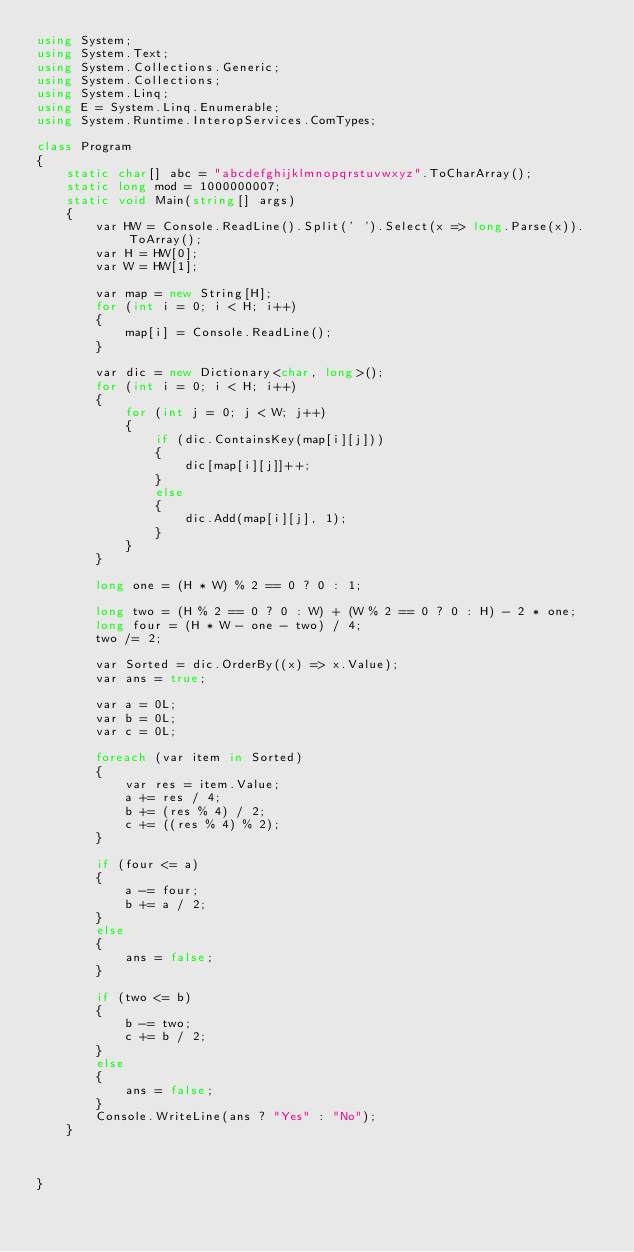Convert code to text. <code><loc_0><loc_0><loc_500><loc_500><_C#_>using System;
using System.Text;
using System.Collections.Generic;
using System.Collections;
using System.Linq;
using E = System.Linq.Enumerable;
using System.Runtime.InteropServices.ComTypes;

class Program
{
    static char[] abc = "abcdefghijklmnopqrstuvwxyz".ToCharArray();
    static long mod = 1000000007;
    static void Main(string[] args)
    {
        var HW = Console.ReadLine().Split(' ').Select(x => long.Parse(x)).ToArray();
        var H = HW[0];
        var W = HW[1];

        var map = new String[H];
        for (int i = 0; i < H; i++)
        {
            map[i] = Console.ReadLine();
        }

        var dic = new Dictionary<char, long>();
        for (int i = 0; i < H; i++)
        {
            for (int j = 0; j < W; j++)
            {
                if (dic.ContainsKey(map[i][j]))
                {
                    dic[map[i][j]]++;
                }
                else
                {
                    dic.Add(map[i][j], 1);
                }
            }
        }

        long one = (H * W) % 2 == 0 ? 0 : 1;

        long two = (H % 2 == 0 ? 0 : W) + (W % 2 == 0 ? 0 : H) - 2 * one;
        long four = (H * W - one - two) / 4;
        two /= 2;

        var Sorted = dic.OrderBy((x) => x.Value);
        var ans = true;

        var a = 0L;
        var b = 0L;
        var c = 0L;

        foreach (var item in Sorted)
        {
            var res = item.Value;
            a += res / 4;
            b += (res % 4) / 2;
            c += ((res % 4) % 2);
        }

        if (four <= a)
        {
            a -= four;
            b += a / 2;
        }
        else
        {
            ans = false;
        }

        if (two <= b)
        {
            b -= two;
            c += b / 2;
        }
        else
        {
            ans = false;
        }
        Console.WriteLine(ans ? "Yes" : "No");
    }



}
</code> 